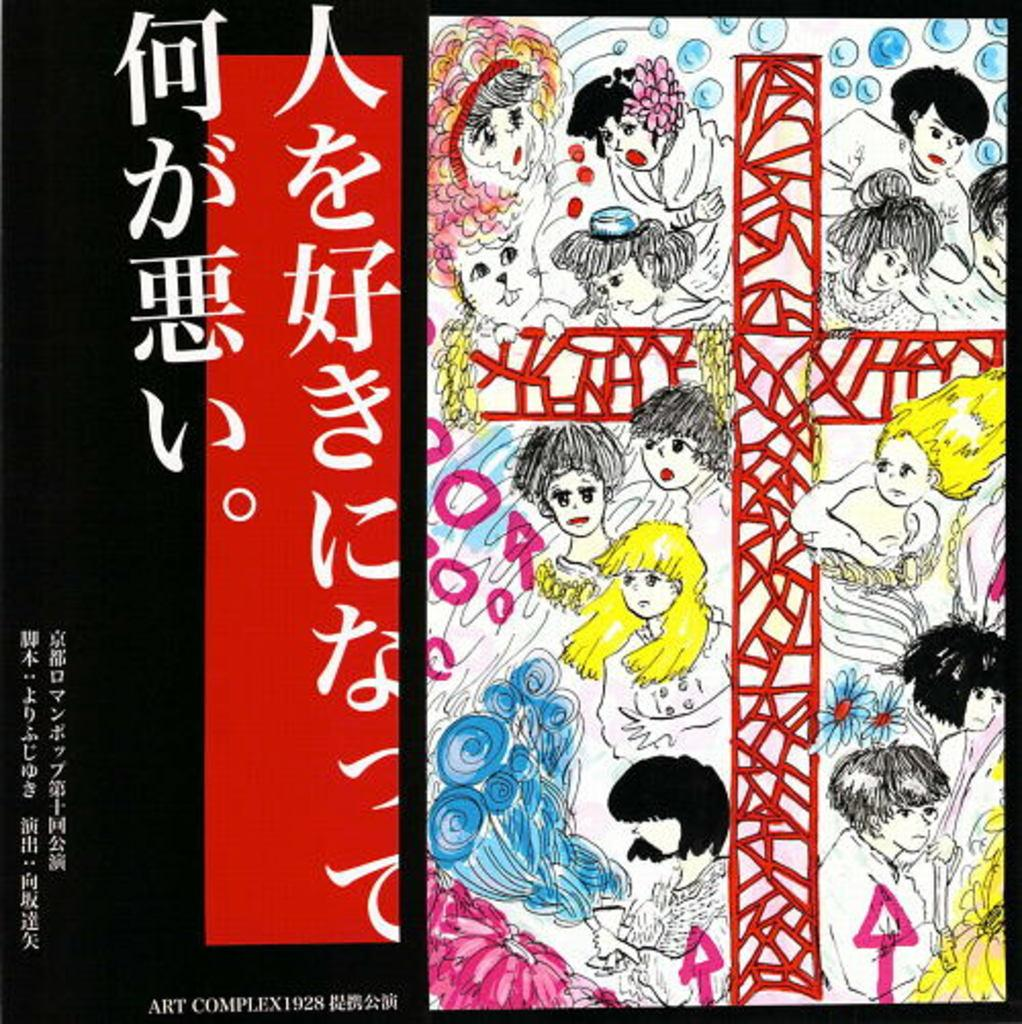What type of pictures are present in the image? There are animated pictures in the image. What else can be found in the image besides the animated pictures? There are words written in the image. Is there any additional information or branding present in the image? Yes, there is a watermark in the image. What colors are used for the watermark? The watermark is black and red in color. Where is the watch located in the image? There is no watch present in the image. What type of patch can be seen on the calendar in the image? There is no calendar or patch present in the image. 